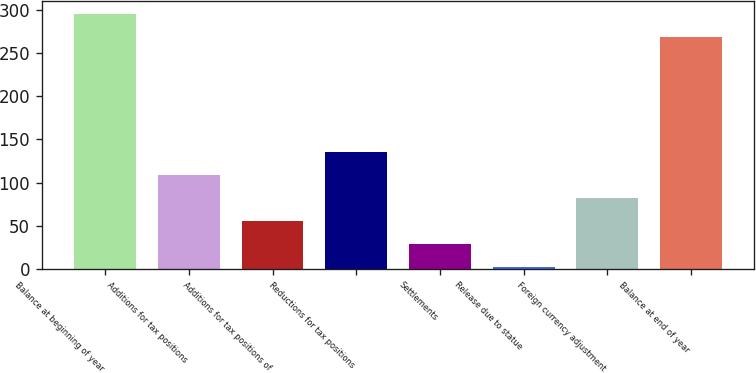<chart> <loc_0><loc_0><loc_500><loc_500><bar_chart><fcel>Balance at beginning of year<fcel>Additions for tax positions<fcel>Additions for tax positions of<fcel>Reductions for tax positions<fcel>Settlements<fcel>Release due to statue<fcel>Foreign currency adjustment<fcel>Balance at end of year<nl><fcel>295.21<fcel>109.04<fcel>55.62<fcel>135.75<fcel>28.91<fcel>2.2<fcel>82.33<fcel>268.5<nl></chart> 